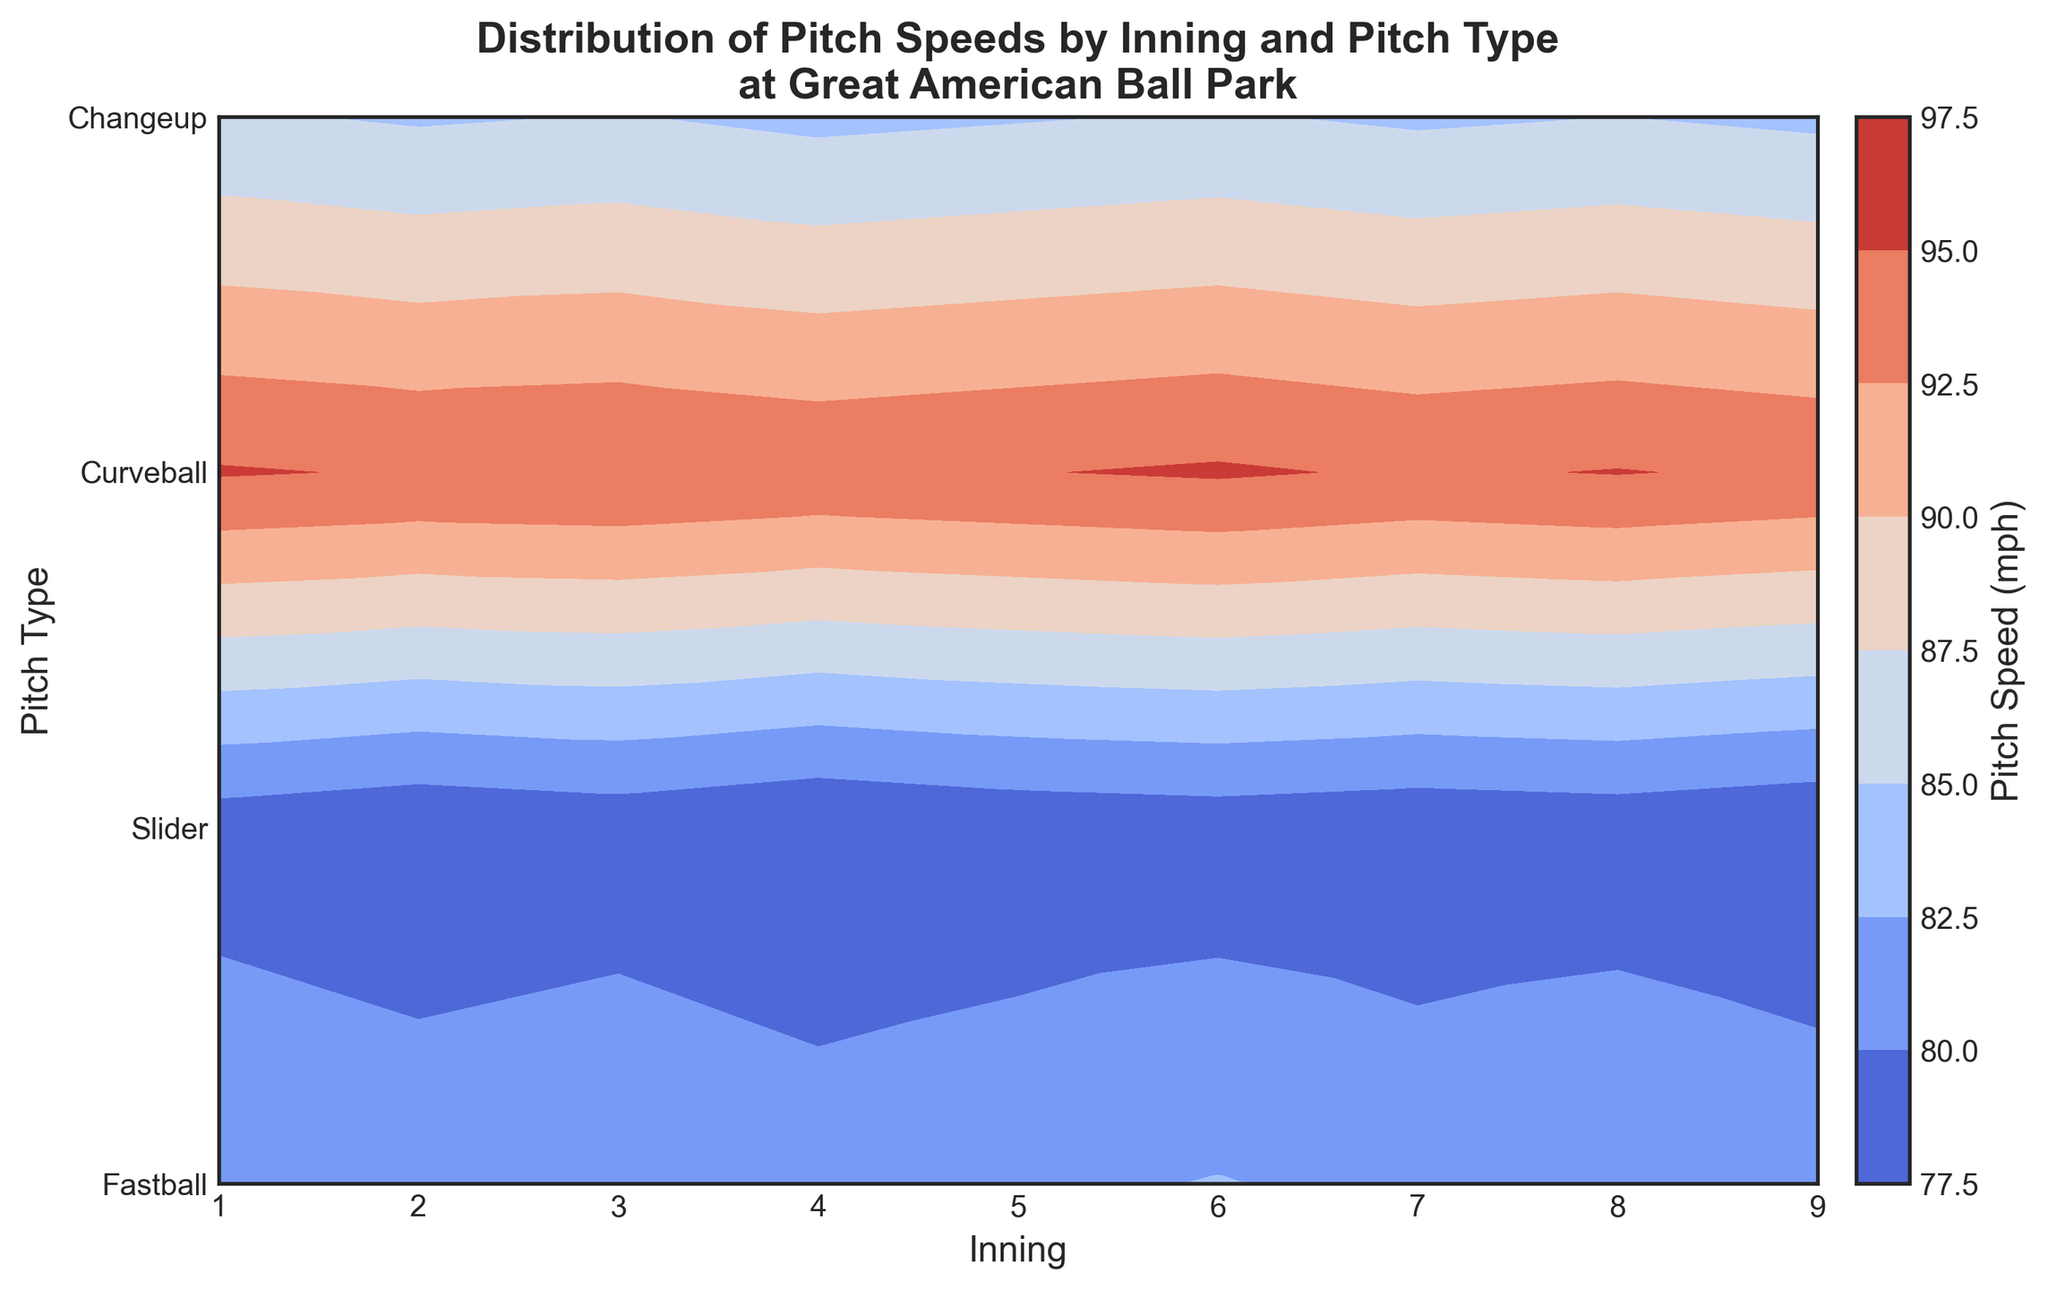What's the highest pitch speed recorded? To identify the highest pitch speed, look at the color gradient in the contour plot and find the region with the darkest red. This indicates the highest pitch speed. Use the color bar to match the darkest red to its corresponding speed value.
Answer: 95.3 mph Which inning shows the lowest average pitch speed? For each inning, look at the color intensity of all pitch types. Blue shades indicate lower speeds, so we sum the speeds for each pitch type and compare across innings. Calculate and compare the averages: Inning 1: (95.2 + 85.3 + 78.6 + 82.5)/4 = 85.4; Inning 2: (94.8 + 84.7 + 77.9 + 81.8)/4 = 84.8; and so on. Inning 4 has the lowest average pitch speed of 84.5 mph.
Answer: Inning 4 Do fastballs generally have higher speeds than curveballs? Look at the pitches labeled as fastballs and curveballs across all innings in the contour plot. Compare the colors associated with fastballs (which should be more on the red side) to those of curveballs (which should be more on the blue side). Fastballs consistently have higher speeds compared to curveballs.
Answer: Yes Which pitch type shows the greatest variation in speeds across innings? To determine this, look at the range of colors for each pitch type. Fastballs have the least variation, with a narrow range primarily in red hues, while sliders, curveballs, and changeups show more variation. Curveballs appear to have a wide range of colors from dark blue to light blue.
Answer: Curveball In which inning is the curveball the fastest? Find the curveball row in the contour plot and look for the inning where the curveball speed is the highest by identifying the darkest shade of blue in that row. The curveball appears to be the fastest in the 6th inning.
Answer: Inning 6 Are there any innings where the pitch speeds are almost the same across all pitch types? Look for innings where the colors for different pitch types are similar, indicating similar speeds. In inning 7, all pitch types have nearly the same speed, showcasing blue-greenish hues without much variation.
Answer: Inning 7 